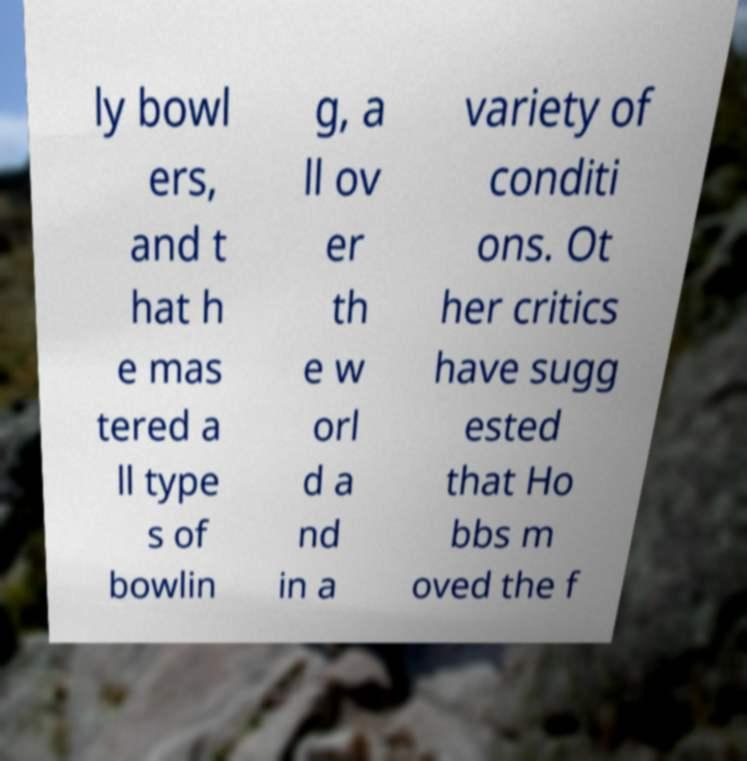Can you accurately transcribe the text from the provided image for me? ly bowl ers, and t hat h e mas tered a ll type s of bowlin g, a ll ov er th e w orl d a nd in a variety of conditi ons. Ot her critics have sugg ested that Ho bbs m oved the f 